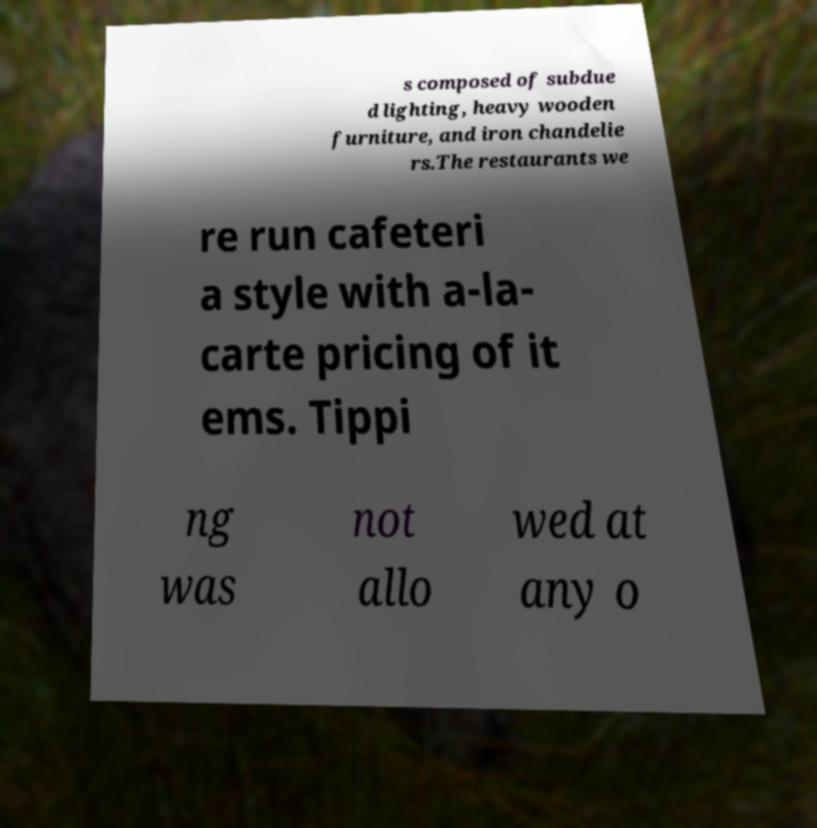What messages or text are displayed in this image? I need them in a readable, typed format. s composed of subdue d lighting, heavy wooden furniture, and iron chandelie rs.The restaurants we re run cafeteri a style with a-la- carte pricing of it ems. Tippi ng was not allo wed at any o 